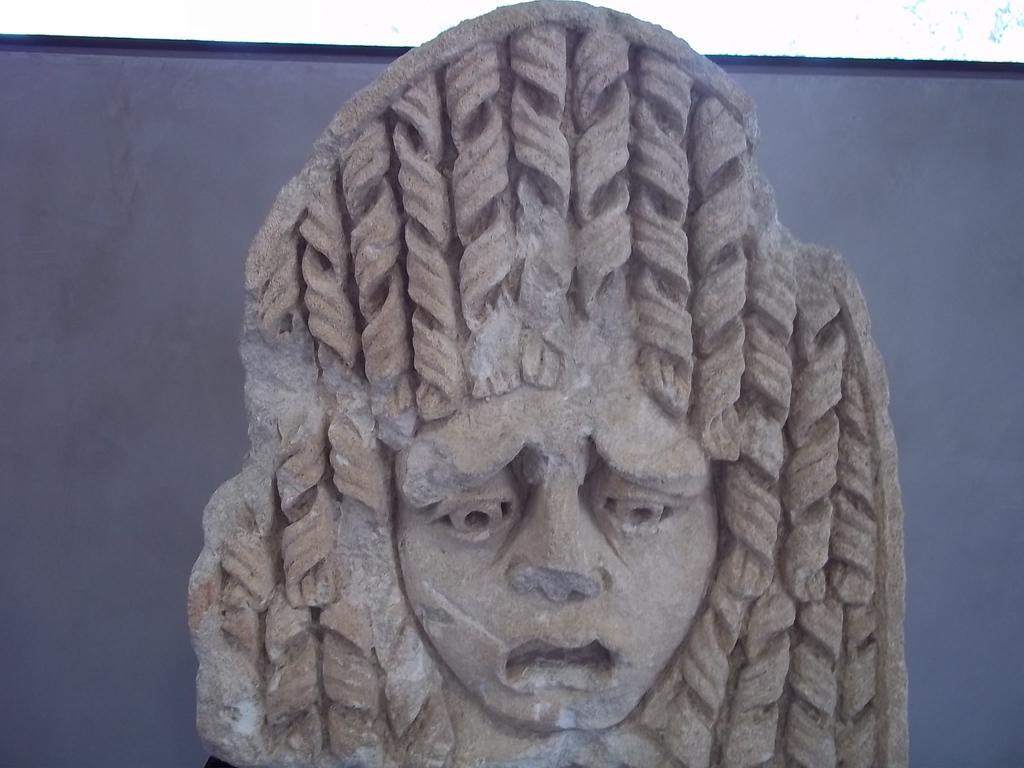Can you describe this image briefly? In the center of the image we can see a statue. 